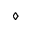Convert formula to latex. <formula><loc_0><loc_0><loc_500><loc_500>\diamond</formula> 